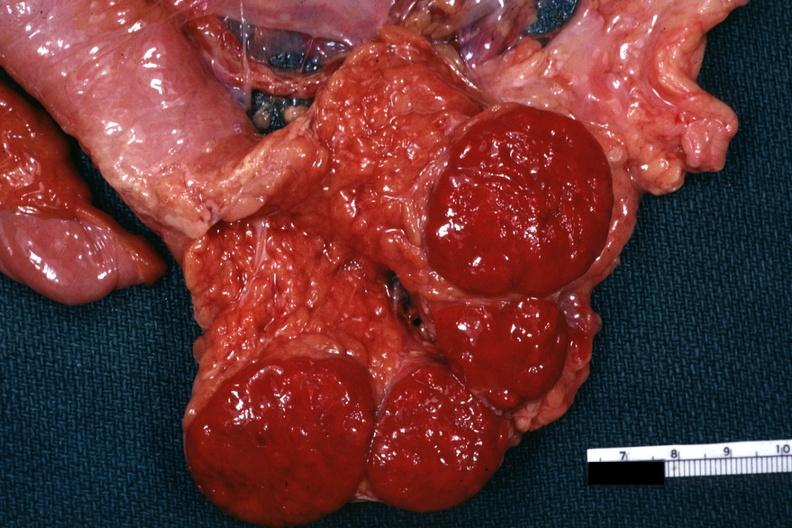what is present?
Answer the question using a single word or phrase. Accessory spleens 